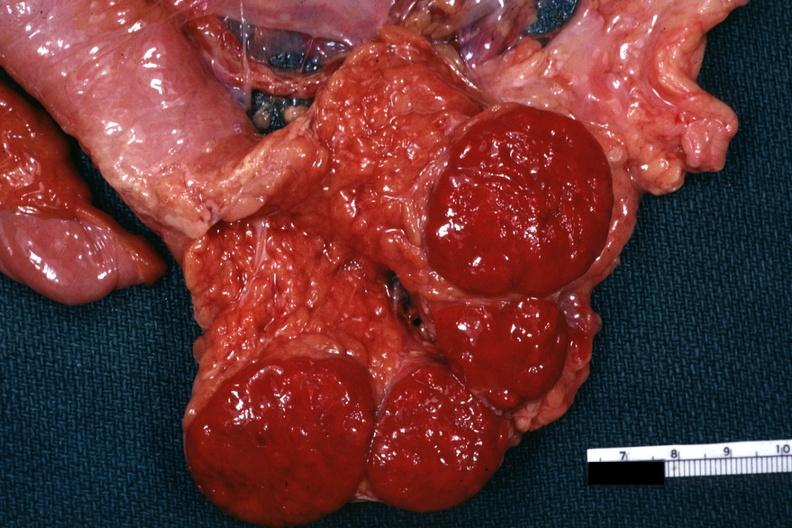what is present?
Answer the question using a single word or phrase. Accessory spleens 